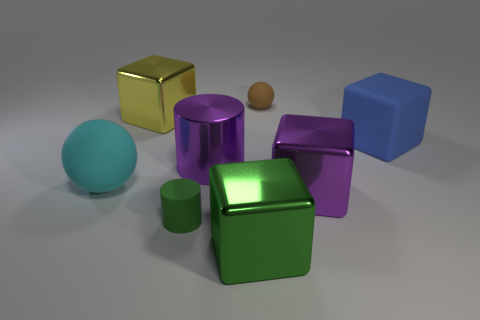What might be the function of the small brown object in relation to the other items? In the context of this image, the small brown object doesn't seem to serve any practical function in relation to the other items. It appears to be a simple rubber sphere, potentially a small bouncy ball, which in a real-world setting, could be used for play. 